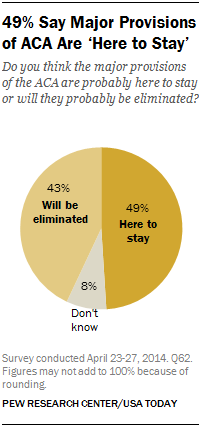Specify some key components in this picture. I am unsure of what 8 percent represents. The value difference between 'Here to stay' and 'Will be eliminated' is 6. 